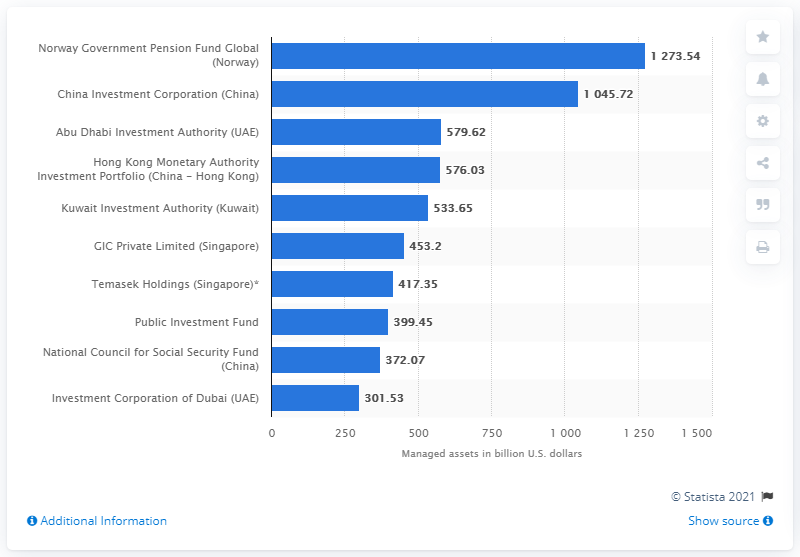Highlight a few significant elements in this photo. As of February 2021, the Norway Government Pension Fund managed a total of 1273.54 US dollars in its operations. 